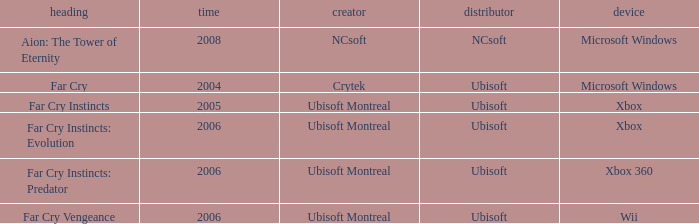What is the average year that has far cry vengeance as the title? 2006.0. Parse the table in full. {'header': ['heading', 'time', 'creator', 'distributor', 'device'], 'rows': [['Aion: The Tower of Eternity', '2008', 'NCsoft', 'NCsoft', 'Microsoft Windows'], ['Far Cry', '2004', 'Crytek', 'Ubisoft', 'Microsoft Windows'], ['Far Cry Instincts', '2005', 'Ubisoft Montreal', 'Ubisoft', 'Xbox'], ['Far Cry Instincts: Evolution', '2006', 'Ubisoft Montreal', 'Ubisoft', 'Xbox'], ['Far Cry Instincts: Predator', '2006', 'Ubisoft Montreal', 'Ubisoft', 'Xbox 360'], ['Far Cry Vengeance', '2006', 'Ubisoft Montreal', 'Ubisoft', 'Wii']]} 